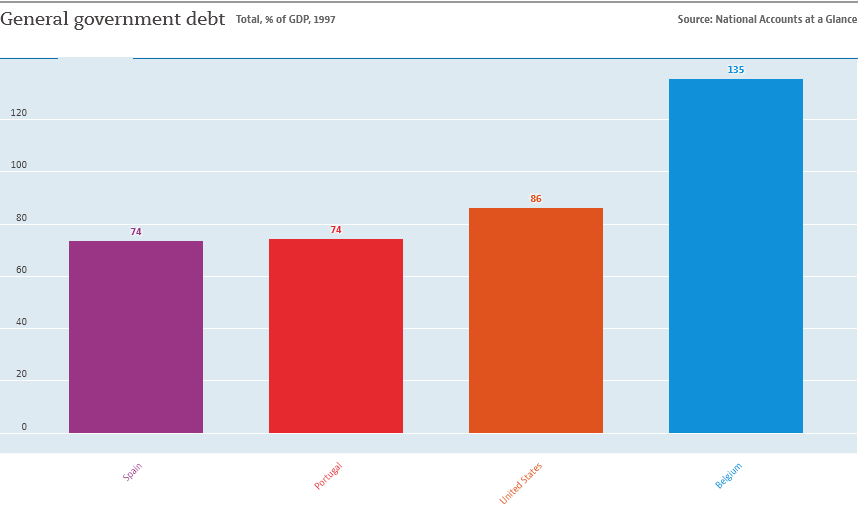Mention a couple of crucial points in this snapshot. The value displayed in the Spain and Portugal datasets is the same. There are a total of 4 bars in the graph. 